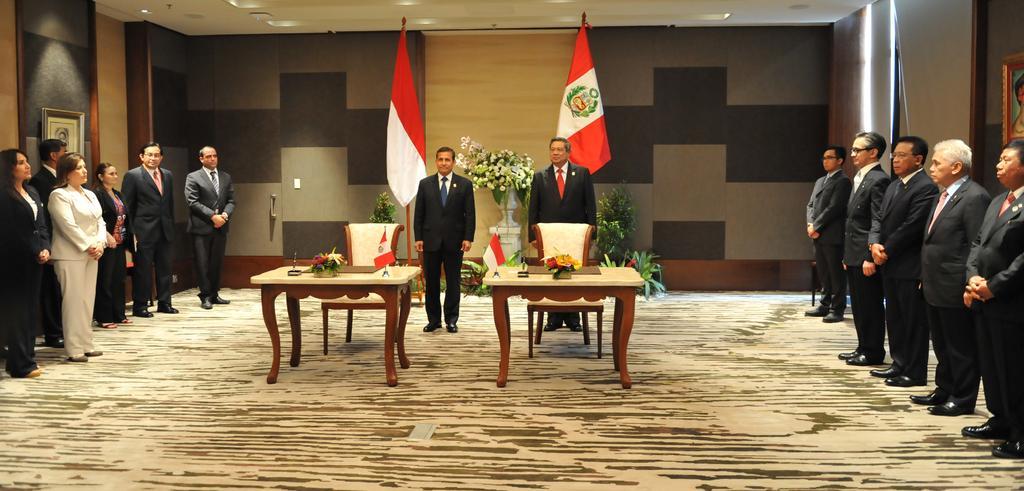Please provide a concise description of this image. On the background of the picture we can see walls and a flower houseplant. We can see two men standing in front of a table where we can see two flower bouquets on the table. this is a floor. At the right and left side of the picture we can see few persons standing and there also photo frames on the wall. 